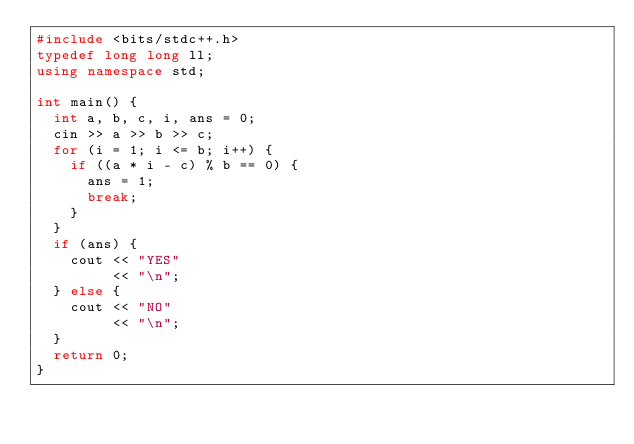Convert code to text. <code><loc_0><loc_0><loc_500><loc_500><_C++_>#include <bits/stdc++.h>
typedef long long ll;
using namespace std;

int main() {
  int a, b, c, i, ans = 0;
  cin >> a >> b >> c;
  for (i = 1; i <= b; i++) {
    if ((a * i - c) % b == 0) {
      ans = 1;
      break;
    }
  }
  if (ans) {
    cout << "YES"
         << "\n";
  } else {
    cout << "NO"
         << "\n";
  }
  return 0;
}</code> 